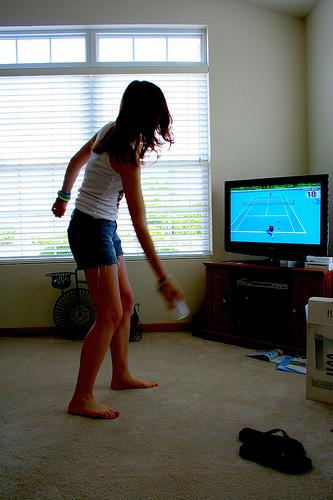Question: where is the picture taken?
Choices:
A. In a forrest.
B. At the beach.
C. In the den.
D. At a concert.
Answer with the letter. Answer: C Question: what is the color of the wall?
Choices:
A. Pink.
B. White.
C. Tan.
D. Green.
Answer with the letter. Answer: B Question: what is the color of the carpet?
Choices:
A. Grey.
B. Blue.
C. Brown.
D. White.
Answer with the letter. Answer: A Question: how many people are there?
Choices:
A. 2.
B. 1.
C. 3.
D. 4.
Answer with the letter. Answer: B Question: where is the window?
Choices:
A. Wall.
B. Ceiling.
C. Above bed.
D. In door.
Answer with the letter. Answer: A 